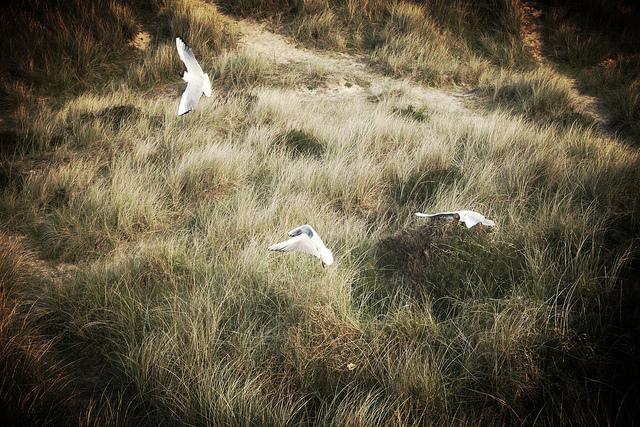What type of animals are these?
Give a very brief answer. Birds. Is the bird flying?
Quick response, please. Yes. Is the grass short?
Keep it brief. No. Are all the birds flying?
Answer briefly. Yes. Is this a painting or real?
Keep it brief. Real. How many animals are depicted?
Short answer required. 3. Is this bird a nurturing animal?
Concise answer only. No. What has fallen?
Concise answer only. Bird. How many birds are there?
Short answer required. 3. How many birds?
Short answer required. 3. 